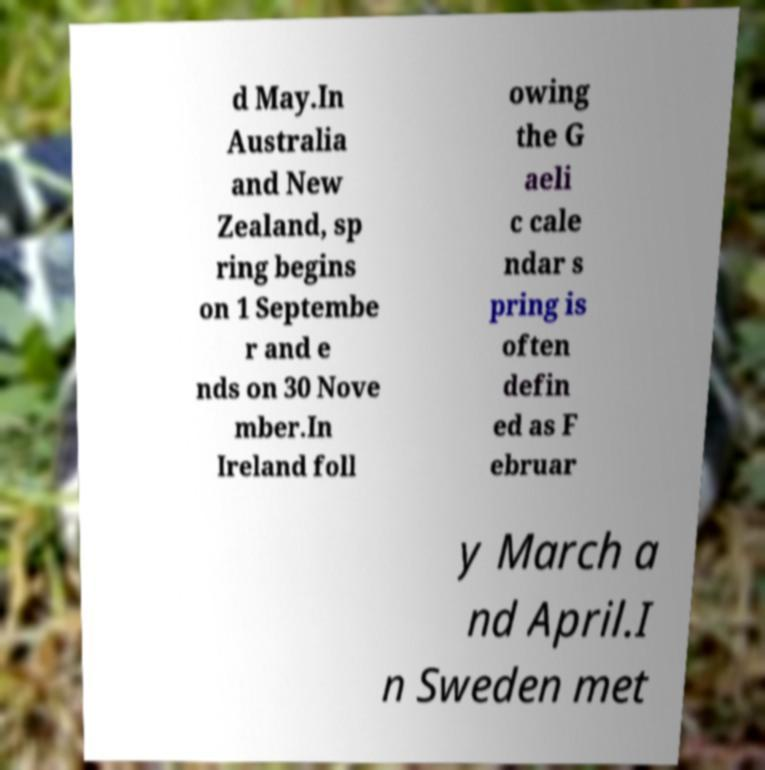Could you assist in decoding the text presented in this image and type it out clearly? d May.In Australia and New Zealand, sp ring begins on 1 Septembe r and e nds on 30 Nove mber.In Ireland foll owing the G aeli c cale ndar s pring is often defin ed as F ebruar y March a nd April.I n Sweden met 